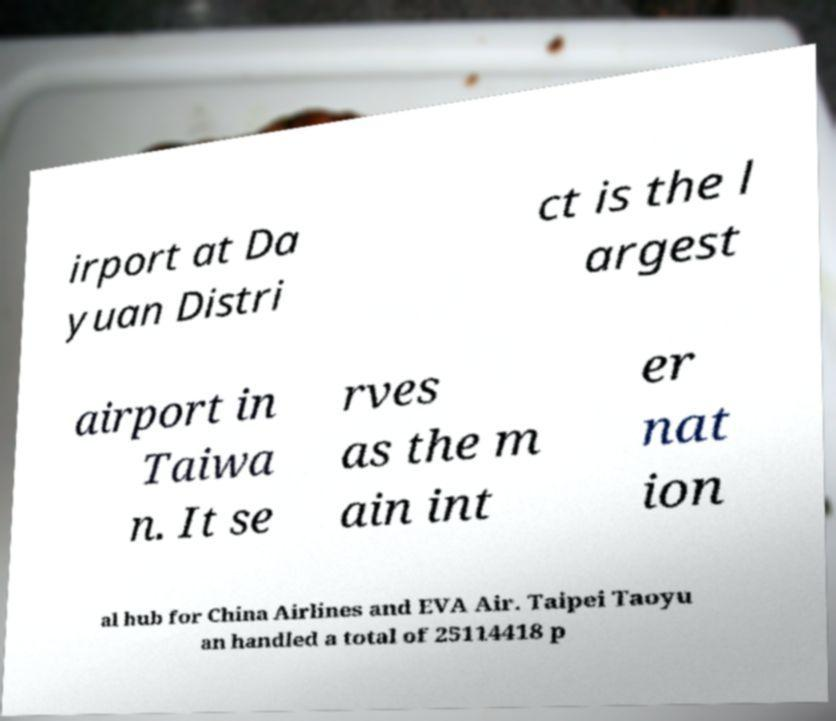For documentation purposes, I need the text within this image transcribed. Could you provide that? irport at Da yuan Distri ct is the l argest airport in Taiwa n. It se rves as the m ain int er nat ion al hub for China Airlines and EVA Air. Taipei Taoyu an handled a total of 25114418 p 